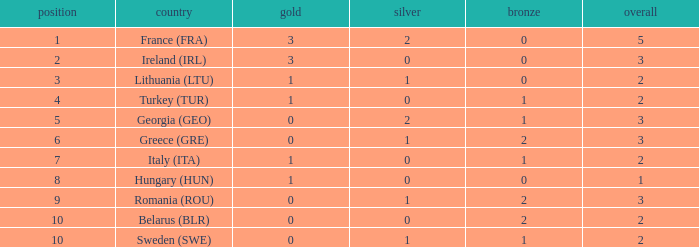What's the total of rank 8 when Silver medals are 0 and gold is more than 1? 0.0. 